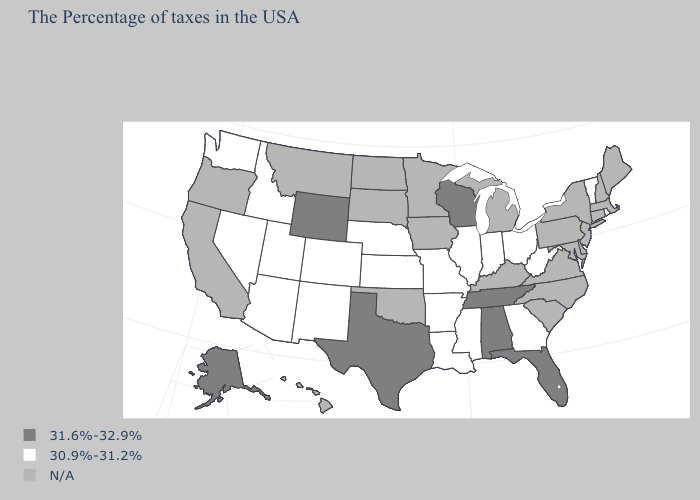What is the value of Nevada?
Concise answer only. 30.9%-31.2%. Does the map have missing data?
Be succinct. Yes. Which states have the highest value in the USA?
Be succinct. Florida, Alabama, Tennessee, Wisconsin, Texas, Wyoming, Alaska. Which states have the highest value in the USA?
Write a very short answer. Florida, Alabama, Tennessee, Wisconsin, Texas, Wyoming, Alaska. Which states have the lowest value in the USA?
Concise answer only. Rhode Island, Vermont, West Virginia, Ohio, Georgia, Indiana, Illinois, Mississippi, Louisiana, Missouri, Arkansas, Kansas, Nebraska, Colorado, New Mexico, Utah, Arizona, Idaho, Nevada, Washington. What is the value of West Virginia?
Give a very brief answer. 30.9%-31.2%. What is the lowest value in the USA?
Keep it brief. 30.9%-31.2%. What is the lowest value in the West?
Quick response, please. 30.9%-31.2%. Name the states that have a value in the range 31.6%-32.9%?
Write a very short answer. Florida, Alabama, Tennessee, Wisconsin, Texas, Wyoming, Alaska. Among the states that border Oklahoma , which have the lowest value?
Keep it brief. Missouri, Arkansas, Kansas, Colorado, New Mexico. What is the value of Arkansas?
Be succinct. 30.9%-31.2%. What is the value of Kansas?
Give a very brief answer. 30.9%-31.2%. What is the highest value in states that border Michigan?
Give a very brief answer. 31.6%-32.9%. 